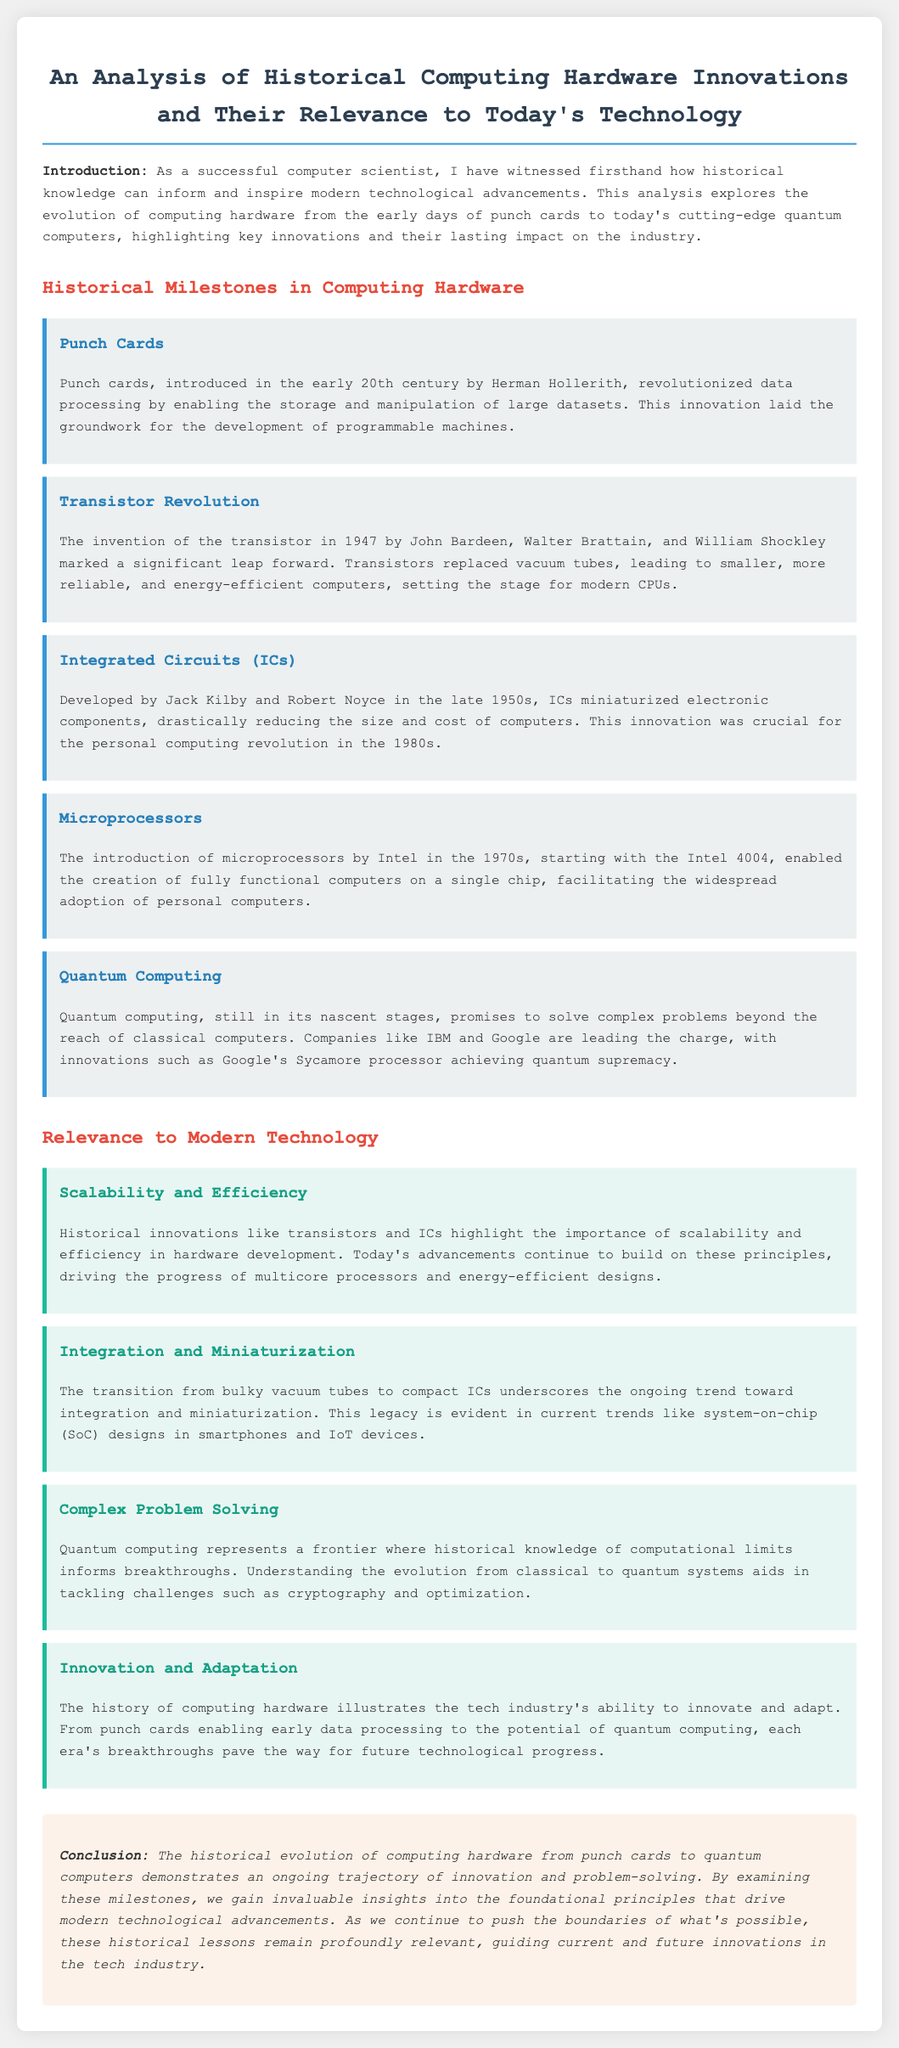What innovation laid the groundwork for programmable machines? The document states that punch cards revolutionized data processing, enabling the storage and manipulation of large datasets, which laid the groundwork for programmable machines.
Answer: Punch cards Who introduced the transistor? The document mentions that the transistor was invented by John Bardeen, Walter Brattain, and William Shockley in 1947.
Answer: John Bardeen, Walter Brattain, and William Shockley What significant leap did transistors provide over vacuum tubes? The text indicates that transistors replaced vacuum tubes, leading to smaller, more reliable, and energy-efficient computers.
Answer: Smaller, more reliable, and energy-efficient computers In what decade were microprocessors introduced? According to the document, microprocessors were introduced by Intel in the 1970s.
Answer: 1970s What is the significance of quantum computing in the document? The document states that quantum computing promises to solve complex problems beyond the reach of classical computers, marking it as a significant advancement in technology.
Answer: Solve complex problems What principle is highlighted by the evolution from transistors to modern multicore processors? The document emphasizes the importance of scalability and efficiency in hardware development, derived from historical innovations like transistors.
Answer: Scalability and efficiency What does the transition from vacuum tubes to integrated circuits represent? The text notes that this transition underscores the ongoing trend toward integration and miniaturization in computing hardware.
Answer: Integration and miniaturization How does quantum computing relate to historical knowledge? The document explains that understanding the evolution from classical to quantum systems aids in resolving challenges such as cryptography and optimization.
Answer: Resolving challenges like cryptography and optimization What overarching theme does the conclusion of the document emphasize? The conclusion highlights the ongoing trajectory of innovation and problem-solving within the evolution of computing hardware.
Answer: Innovation and problem-solving 